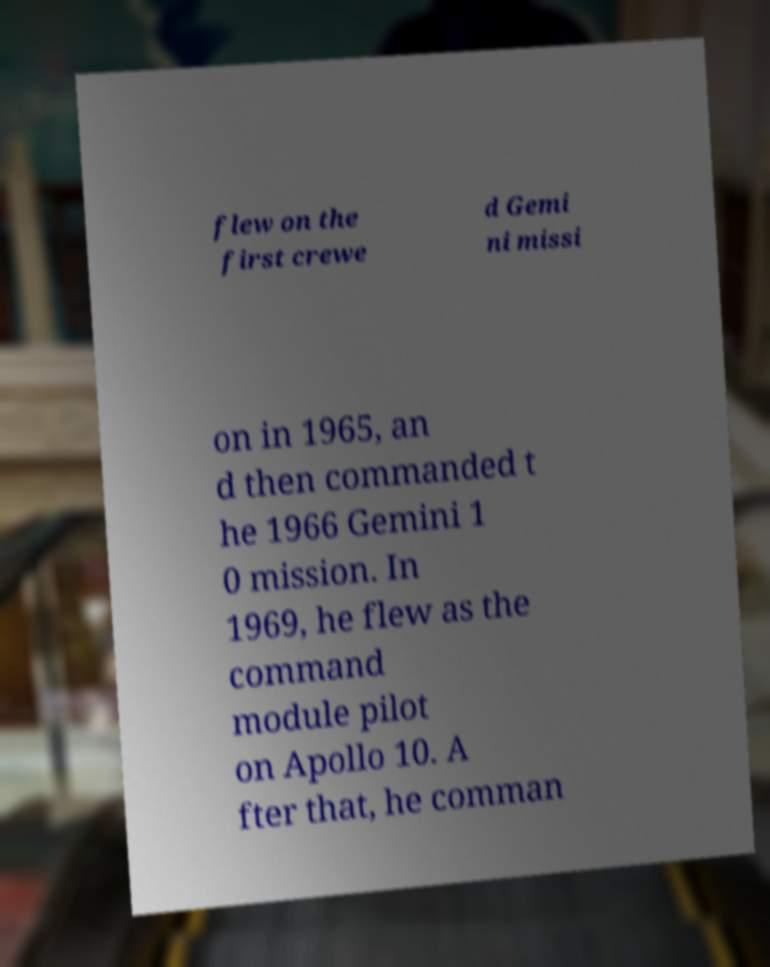There's text embedded in this image that I need extracted. Can you transcribe it verbatim? flew on the first crewe d Gemi ni missi on in 1965, an d then commanded t he 1966 Gemini 1 0 mission. In 1969, he flew as the command module pilot on Apollo 10. A fter that, he comman 